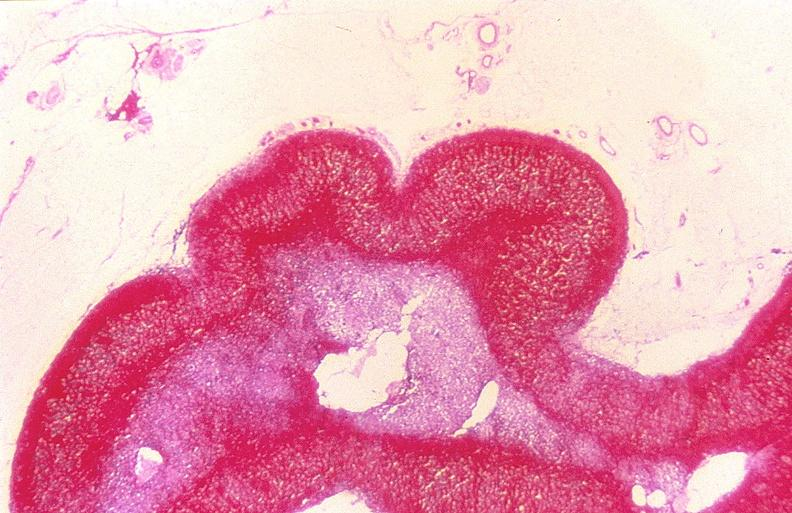s nodule present?
Answer the question using a single word or phrase. No 